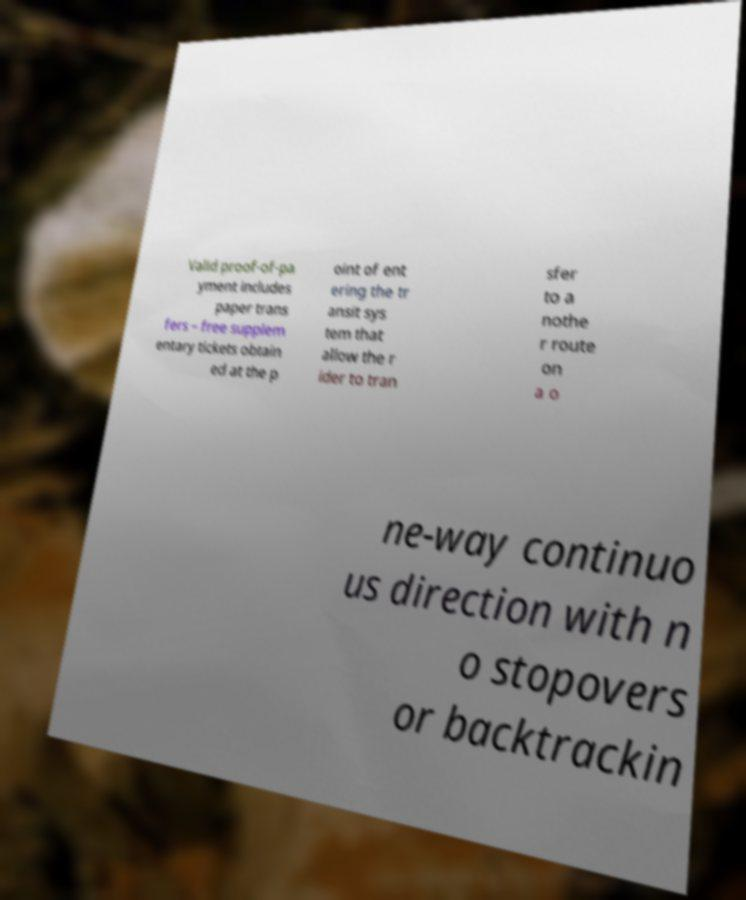For documentation purposes, I need the text within this image transcribed. Could you provide that? Valid proof-of-pa yment includes paper trans fers – free supplem entary tickets obtain ed at the p oint of ent ering the tr ansit sys tem that allow the r ider to tran sfer to a nothe r route on a o ne-way continuo us direction with n o stopovers or backtrackin 